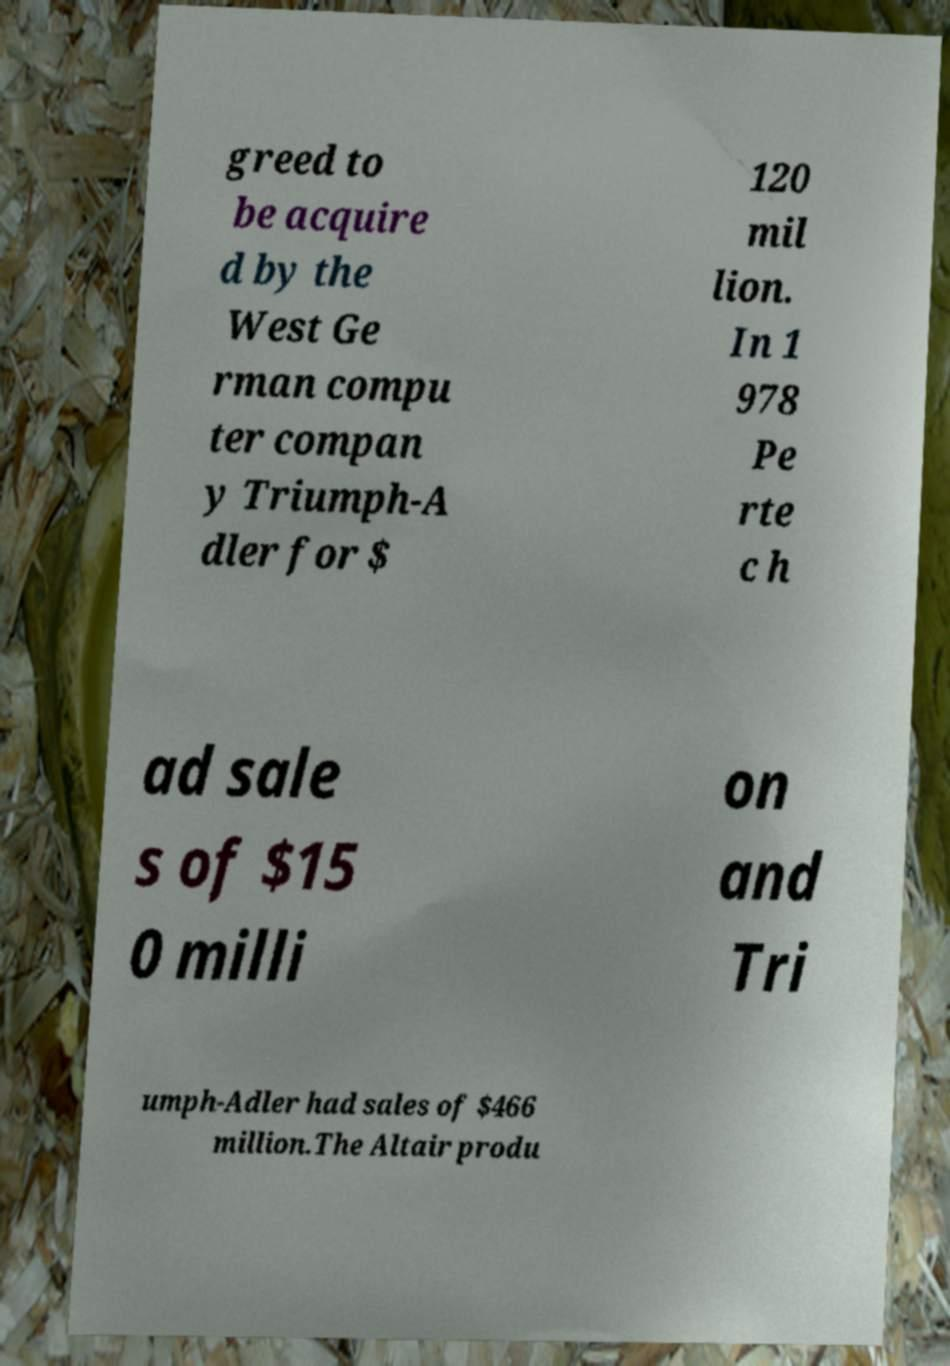Could you extract and type out the text from this image? greed to be acquire d by the West Ge rman compu ter compan y Triumph-A dler for $ 120 mil lion. In 1 978 Pe rte c h ad sale s of $15 0 milli on and Tri umph-Adler had sales of $466 million.The Altair produ 